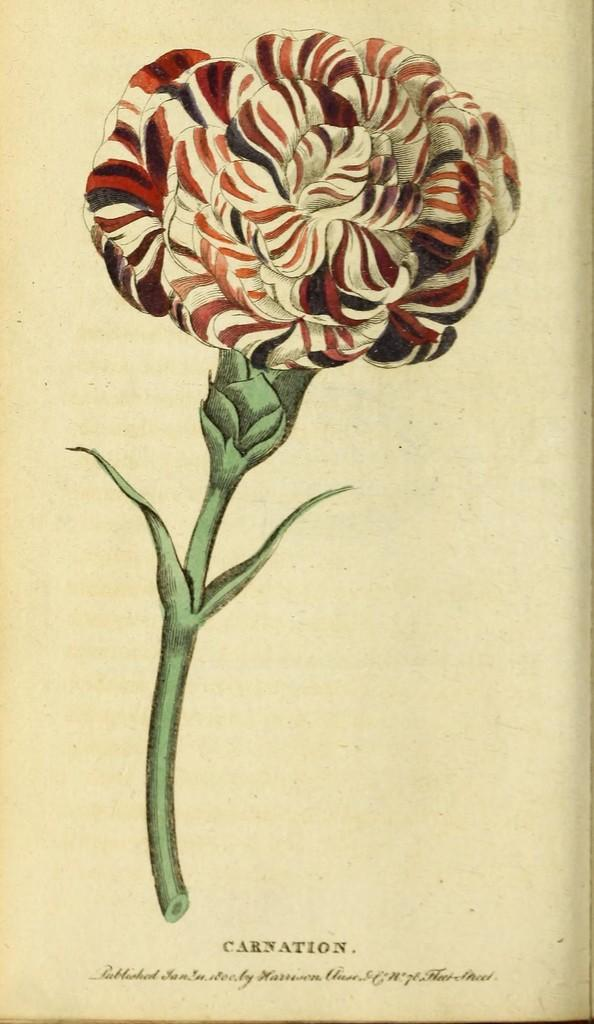What is depicted in the drawing in the image? There is a drawing of a flower in the image. What part of the flower is included in the drawing? The drawing includes a stem. What is the drawing done on? The drawing is on a piece of paper. What can be found at the bottom of the image? There is text at the bottom of the image. What color is the cushion in the image? There is no cushion present in the image. Can you describe the position of the ear in the image? There is no ear present in the image. 